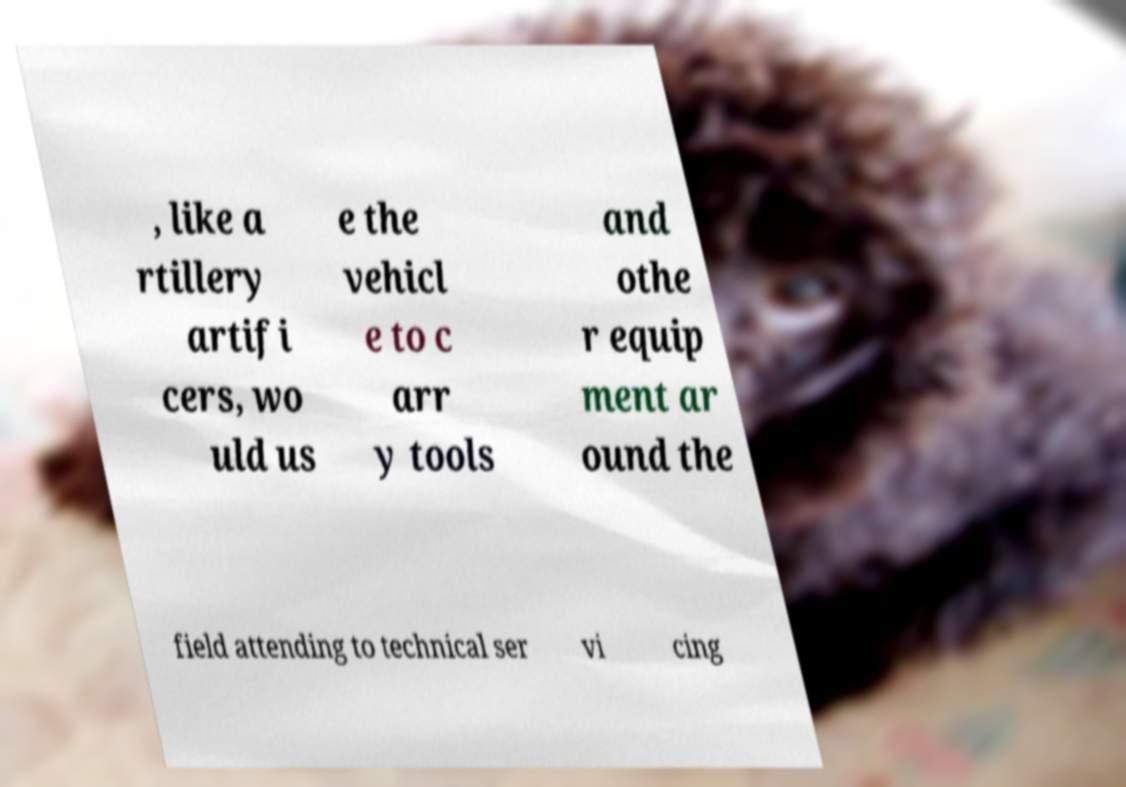I need the written content from this picture converted into text. Can you do that? , like a rtillery artifi cers, wo uld us e the vehicl e to c arr y tools and othe r equip ment ar ound the field attending to technical ser vi cing 